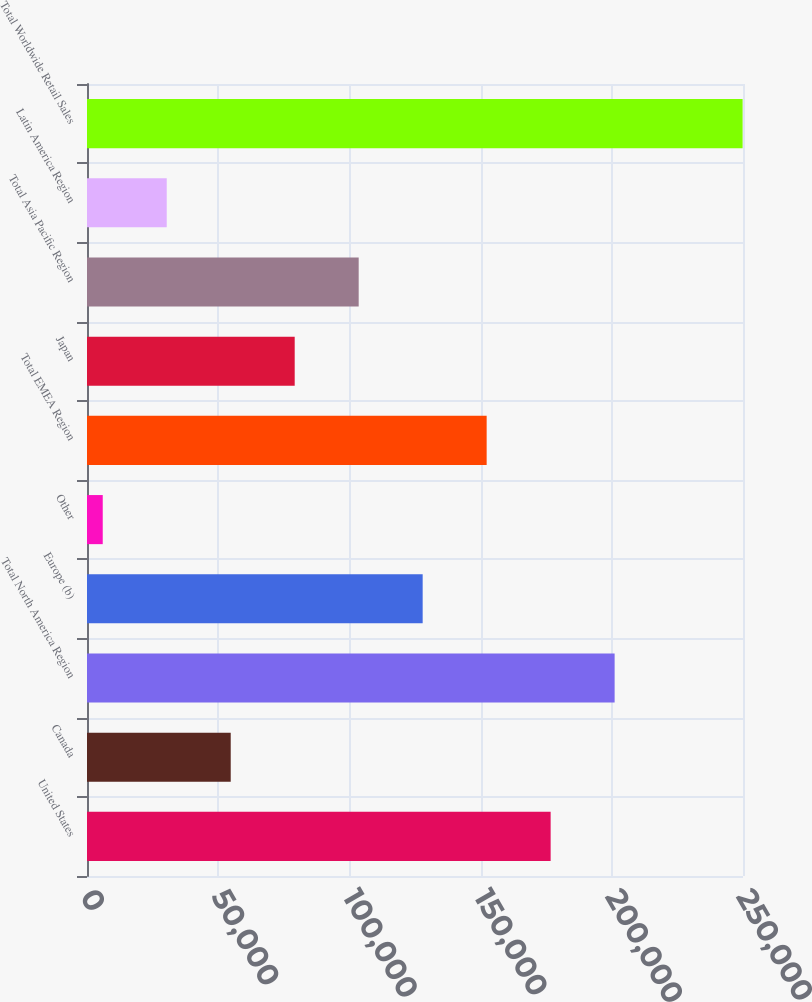Convert chart to OTSL. <chart><loc_0><loc_0><loc_500><loc_500><bar_chart><fcel>United States<fcel>Canada<fcel>Total North America Region<fcel>Europe (b)<fcel>Other<fcel>Total EMEA Region<fcel>Japan<fcel>Total Asia Pacific Region<fcel>Latin America Region<fcel>Total Worldwide Retail Sales<nl><fcel>176694<fcel>54769.8<fcel>201079<fcel>127924<fcel>6000<fcel>152309<fcel>79154.7<fcel>103540<fcel>30384.9<fcel>249849<nl></chart> 